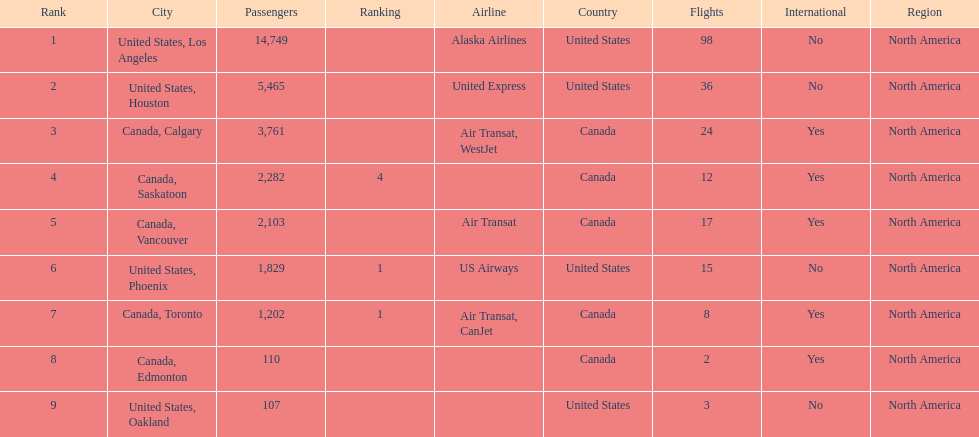What was the total of passengers in phoenix, arizona? 1,829. 